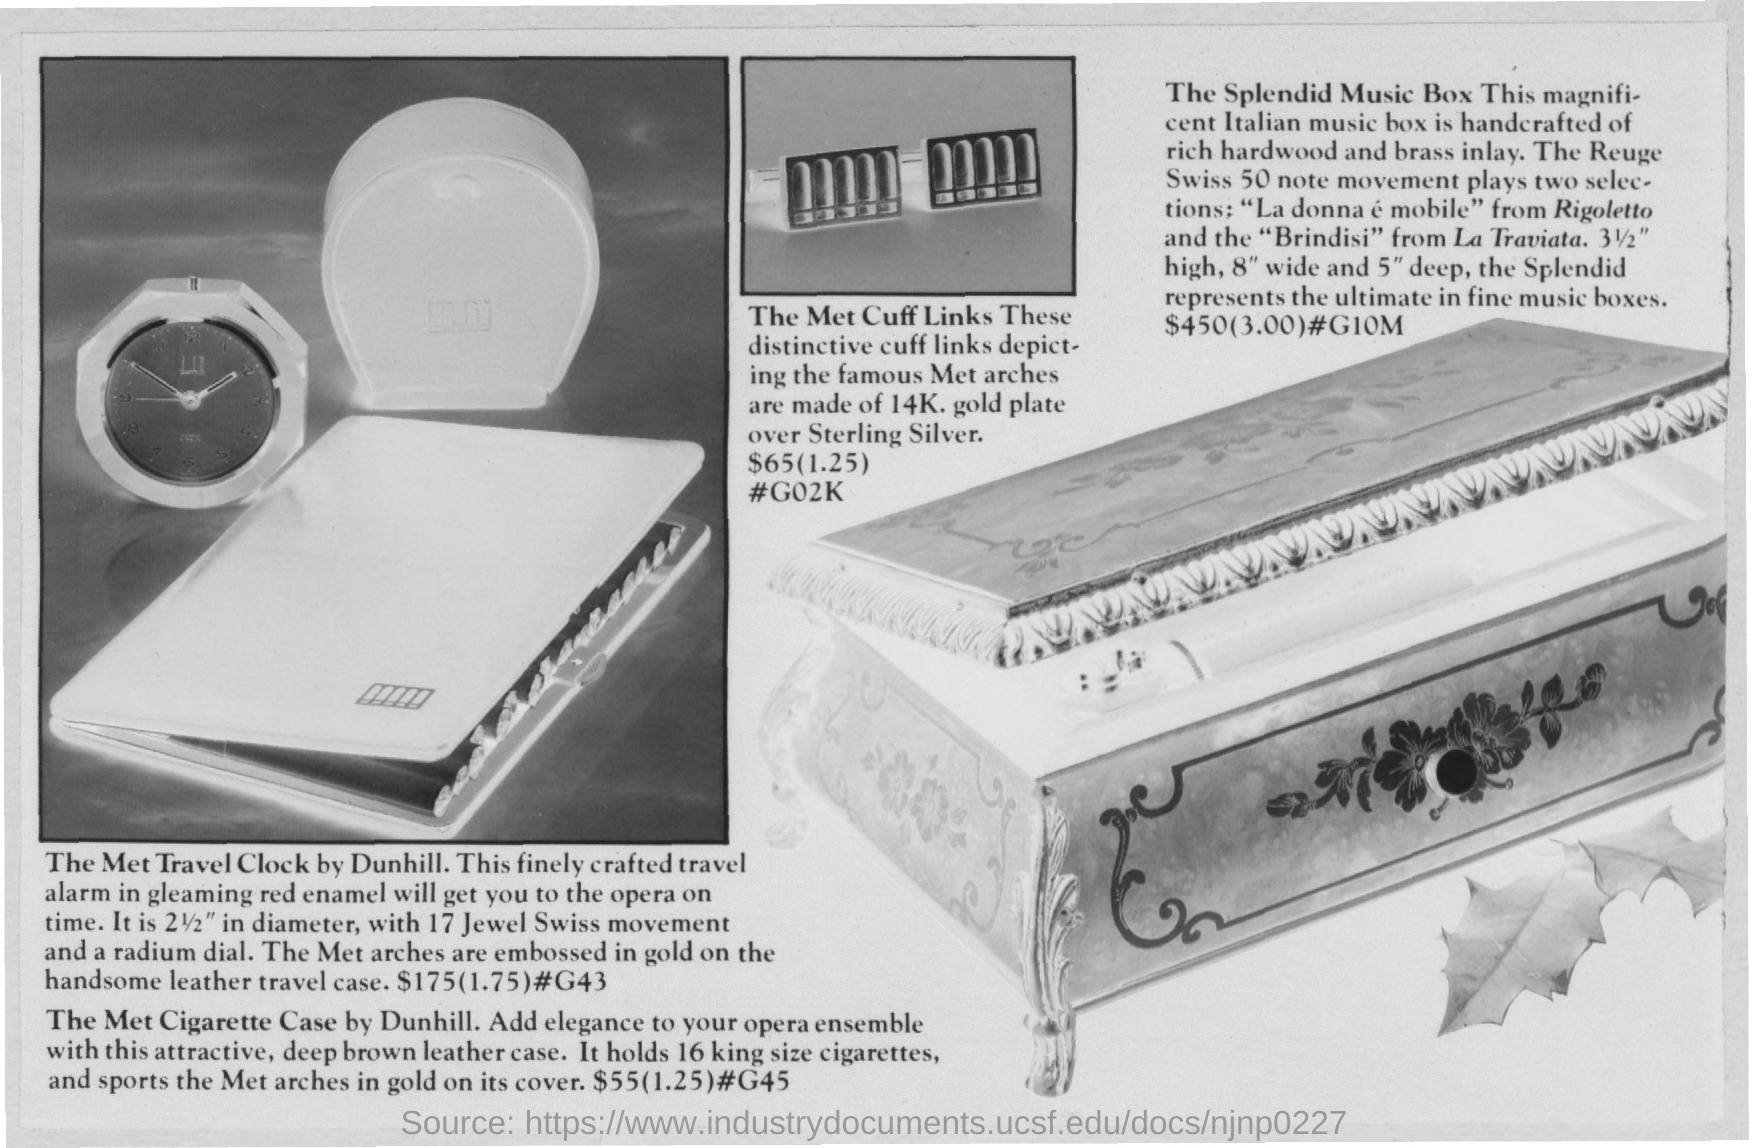What's  the cost of Travel clock?
Your answer should be very brief. $175. 